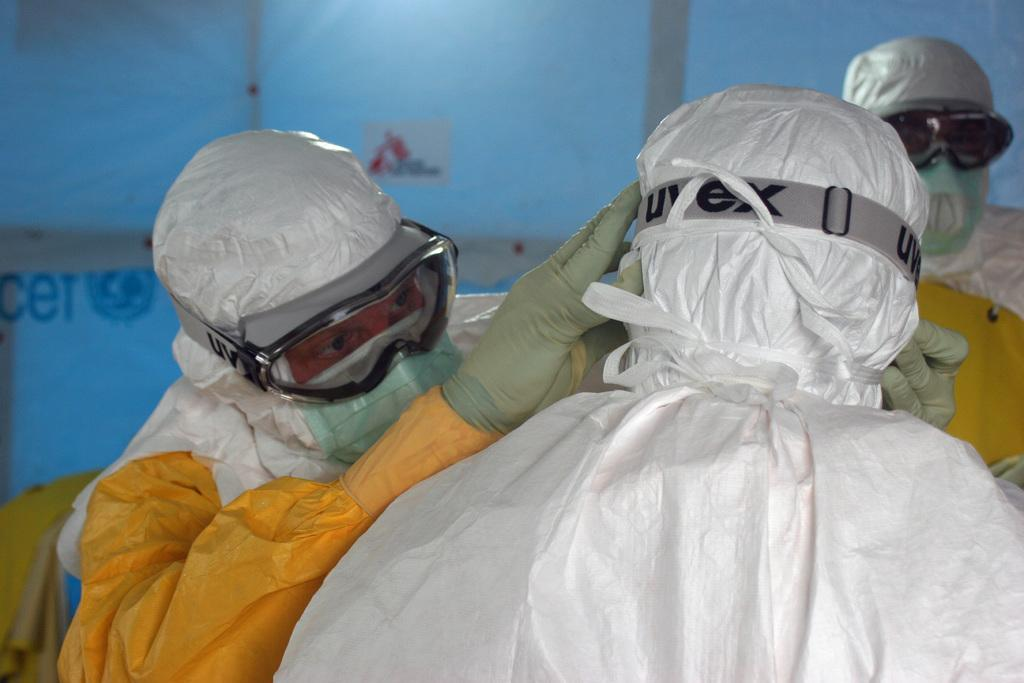What is the man in the image holding? The man is holding an object in the image. How many men are present in the image? There are two men in the image. What can be seen in the background of the image? There appears to be a tent in the background of the image. What is written or depicted on the tent? There is text on the tent. What type of hospital can be seen in the image? There is no hospital present in the image; it features two men and a tent in the background. What message of peace is being conveyed by the competition in the image? There is no competition or message of peace present in the image; it only shows two men and a tent with text. 